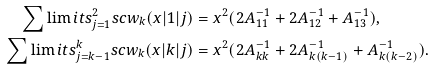<formula> <loc_0><loc_0><loc_500><loc_500>\sum \lim i t s _ { j = 1 } ^ { 2 } s c w _ { k } ( x | 1 | j ) & = x ^ { 2 } ( 2 A ^ { - 1 } _ { 1 1 } + 2 A ^ { - 1 } _ { 1 2 } + A ^ { - 1 } _ { 1 3 } ) , \\ \sum \lim i t s _ { j = k - 1 } ^ { k } s c w _ { k } ( x | k | j ) & = x ^ { 2 } ( 2 A ^ { - 1 } _ { k k } + 2 A ^ { - 1 } _ { k ( k - 1 ) } + A ^ { - 1 } _ { k ( k - 2 ) } ) .</formula> 